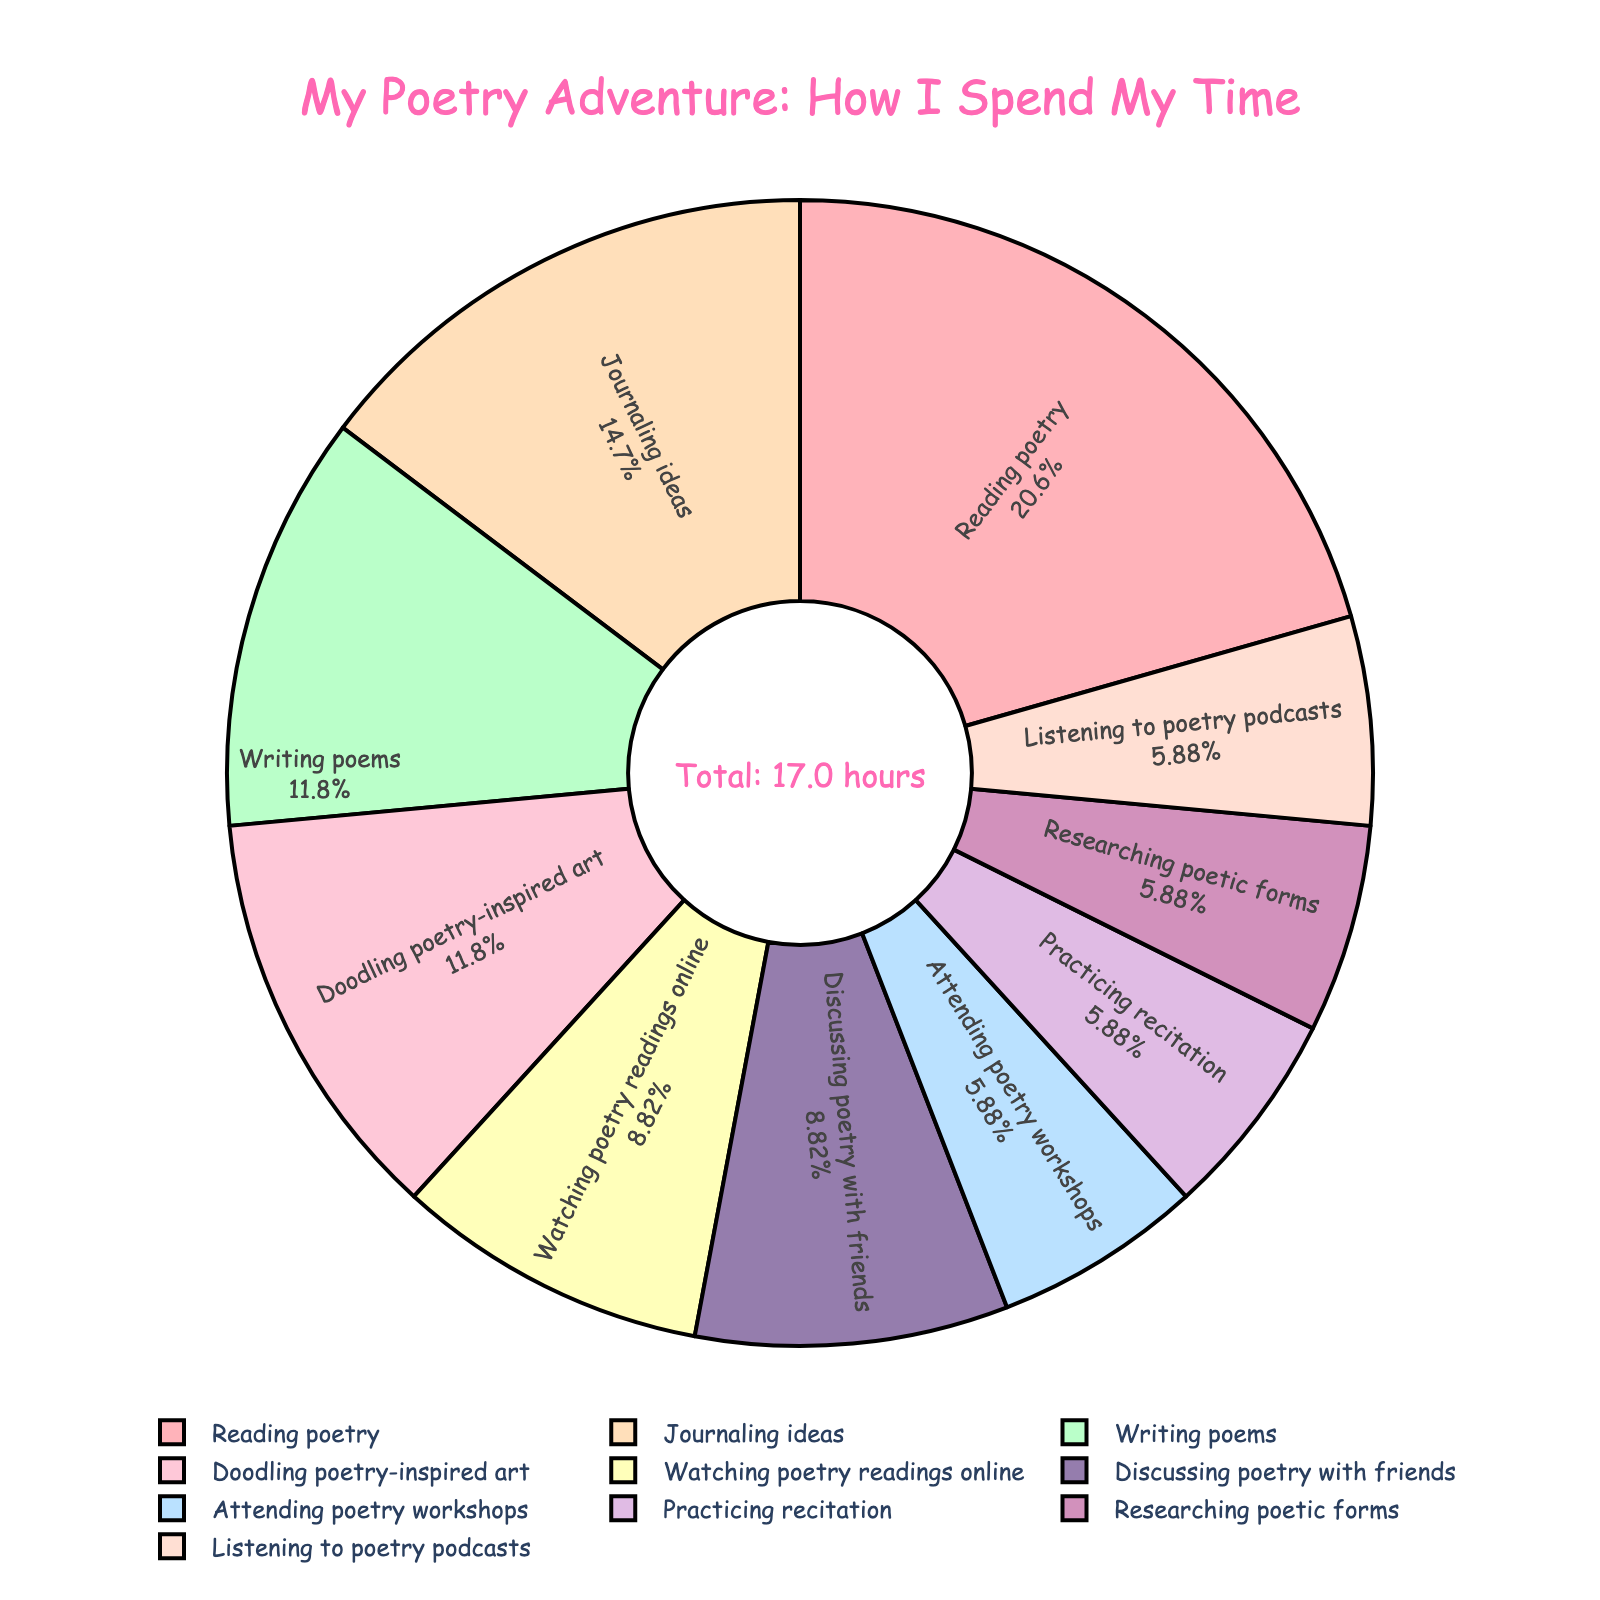What's the total time spent reading poetry and writing poems per week? To find the total time spent reading poetry and writing poems per week, add the two values: 3.5 hours (reading poetry) + 2 hours (writing poems) = 5.5 hours.
Answer: 5.5 hours Which activity do I spend the most time on? The activity with the largest percentage on the pie chart is "Reading poetry," which represents the largest slice of the pie.
Answer: Reading poetry How does the time spent on writing poems compare to journaling ideas? Writing poems is 2 hours per week, and journaling ideas is 2.5 hours per week. Journaling ideas takes more time by 0.5 hours.
Answer: Journaling ideas takes 0.5 hours more Among the activities with equal time spent, which ones are they and how much time is spent on each? The pie chart shows that attending poetry workshops, practicing recitation, and researching poetic forms each take 1 hour per week.
Answer: Attending poetry workshops, practicing recitation, researching poetic forms - 1 hour each What is the percentage of time spent doodling poetry-inspired art? The pie chart provides percentage information for each slice. Doodling poetry-inspired art takes 2 hours per week out of the total 17 hours (sum of all activities). Calculate the percentage: (2/17) * 100 ≈ 11.76%.
Answer: Approximately 11.76% What is the sum of hours spent on watching poetry readings online and discussing poetry with friends? Watching poetry readings online is 1.5 hours per week and discussing poetry with friends is also 1.5 hours per week, thus the sum is: 1.5 hours + 1.5 hours = 3 hours.
Answer: 3 hours Which activity uses the smallest slice of the pie and how much time is spent on it? By observing the pie chart, the smallest slice represents "Attending poetry workshops," "Practicing recitation," "Researching poetic forms," each with 1 hour.
Answer: 1 hour each How much more time is spent on journaling ideas compared to listening to poetry podcasts? Journaling ideas take 2.5 hours per week whereas listening to poetry podcasts takes 1 hour per week. So, the difference is: 2.5 hours - 1 hour = 1.5 hours.
Answer: 1.5 hours If we combine the hours spent on reading poetry, journaling ideas, and doodling poetry-inspired art, what fraction of the total time do they represent? Adding the hours: Reading poetry (3.5) + Journaling ideas (2.5) + Doodling poetry-inspired art (2) = 8 hours. Total hours per week is 17. The fraction is 8/17.
Answer: 8/17 